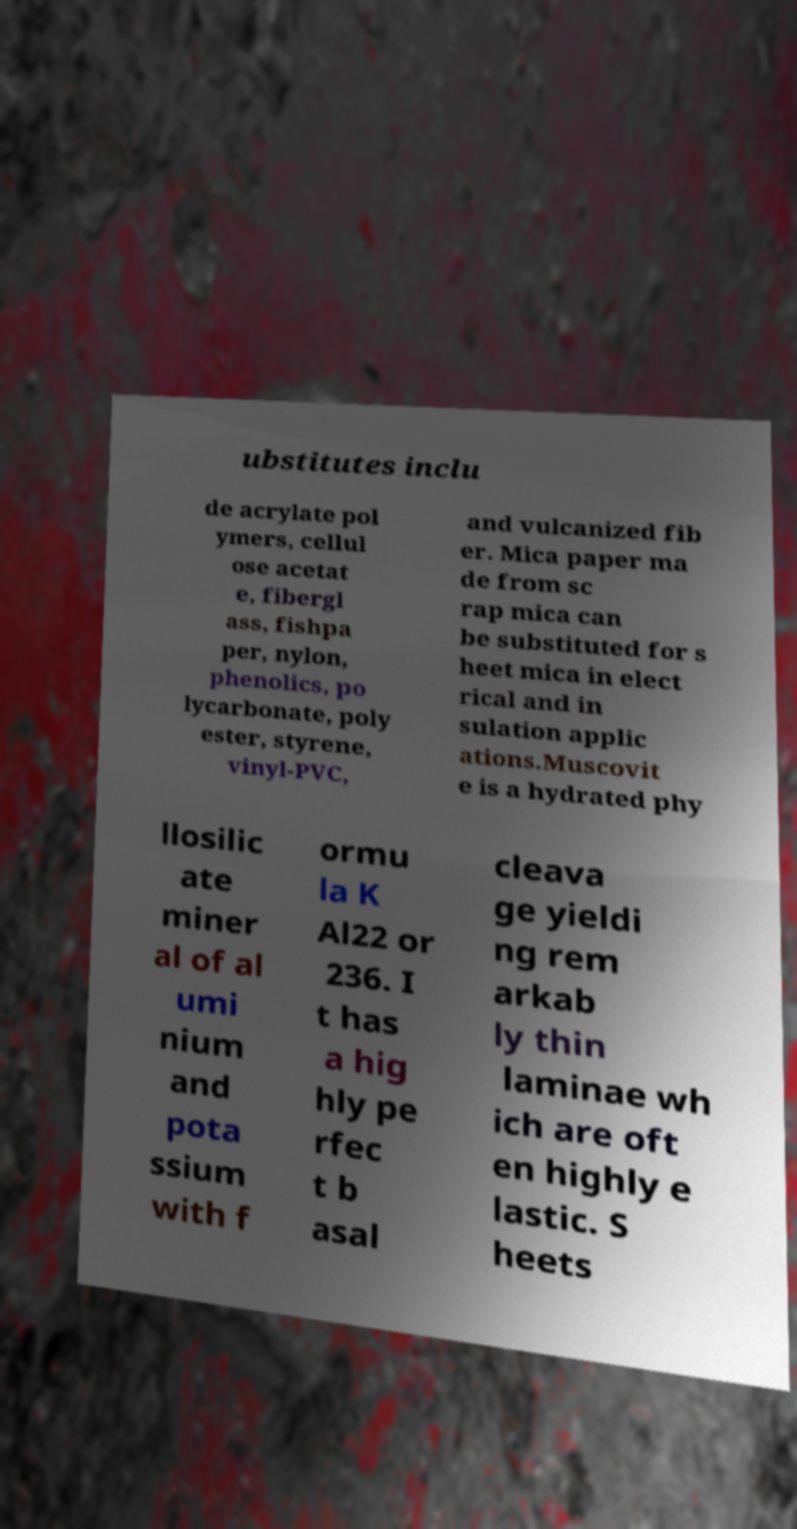I need the written content from this picture converted into text. Can you do that? ubstitutes inclu de acrylate pol ymers, cellul ose acetat e, fibergl ass, fishpa per, nylon, phenolics, po lycarbonate, poly ester, styrene, vinyl-PVC, and vulcanized fib er. Mica paper ma de from sc rap mica can be substituted for s heet mica in elect rical and in sulation applic ations.Muscovit e is a hydrated phy llosilic ate miner al of al umi nium and pota ssium with f ormu la K Al22 or 236. I t has a hig hly pe rfec t b asal cleava ge yieldi ng rem arkab ly thin laminae wh ich are oft en highly e lastic. S heets 